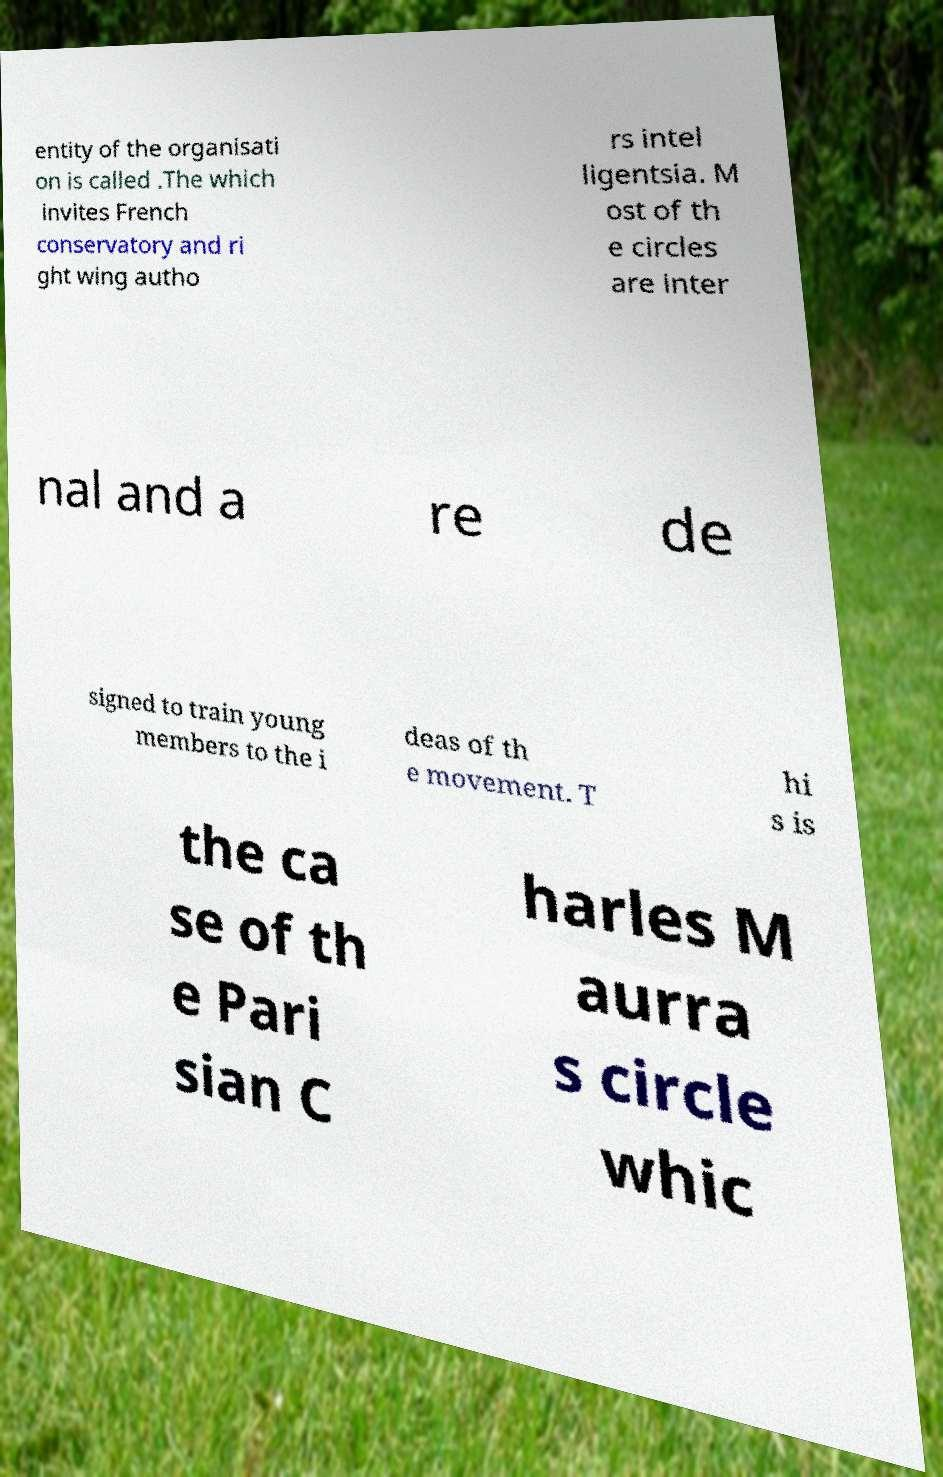Can you read and provide the text displayed in the image?This photo seems to have some interesting text. Can you extract and type it out for me? entity of the organisati on is called .The which invites French conservatory and ri ght wing autho rs intel ligentsia. M ost of th e circles are inter nal and a re de signed to train young members to the i deas of th e movement. T hi s is the ca se of th e Pari sian C harles M aurra s circle whic 